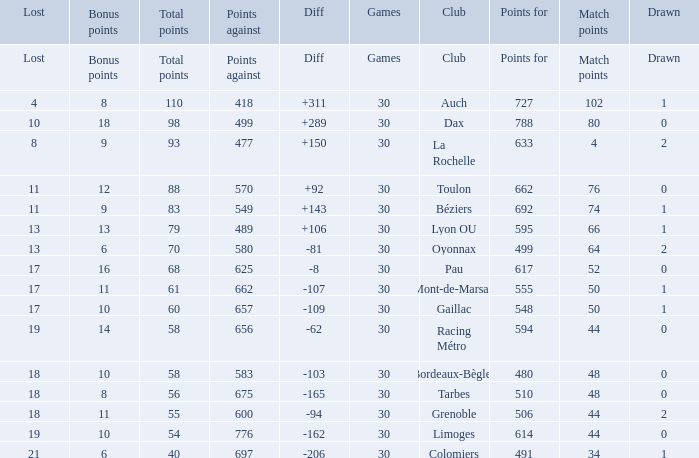What is the number of games for a club that has a value of 595 for points for? 30.0. 